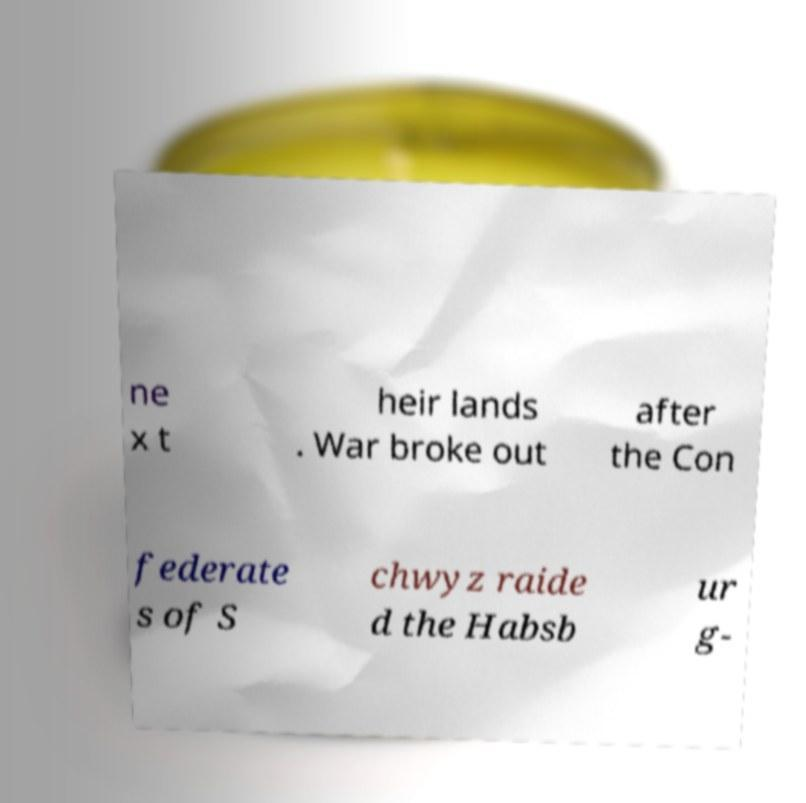What messages or text are displayed in this image? I need them in a readable, typed format. ne x t heir lands . War broke out after the Con federate s of S chwyz raide d the Habsb ur g- 